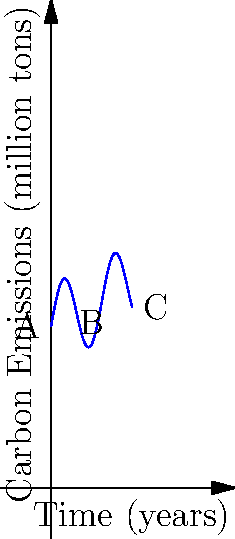The graph shows the carbon emissions of a developing country over a 10-year period. At which point (A, B, or C) is the rate of change in carbon emissions the highest? Explain your reasoning using calculus concepts. To determine where the rate of change in carbon emissions is highest, we need to analyze the slope of the curve at points A, B, and C. The slope represents the instantaneous rate of change, which is given by the derivative of the function at each point.

1. Point A (beginning of the curve):
   The slope appears to be positive and relatively steep.

2. Point B (middle of the curve):
   The slope seems to be close to zero or slightly negative.

3. Point C (end of the curve):
   The slope is positive and appears to be the steepest among the three points.

In calculus terms, we're comparing the values of $\frac{df}{dx}$ at these three points, where $f(x)$ represents the carbon emissions function.

The rate of change is highest where $\left|\frac{df}{dx}\right|$ is greatest. Visually, we can see that the tangent line at point C would have the steepest slope, indicating the highest rate of change.

This analysis suggests that the rate of change in carbon emissions is highest at point C.
Answer: Point C 